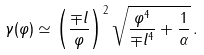Convert formula to latex. <formula><loc_0><loc_0><loc_500><loc_500>\gamma ( \varphi ) \simeq \left ( \frac { \mp l } { \varphi } \right ) ^ { 2 } \sqrt { \frac { \varphi ^ { 4 } } { \mp l ^ { 4 } } + \frac { 1 } { \alpha } } \, .</formula> 